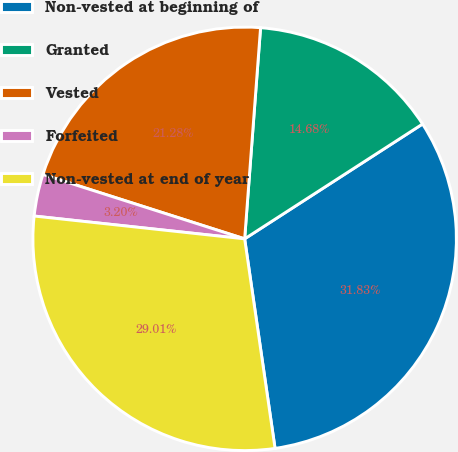Convert chart to OTSL. <chart><loc_0><loc_0><loc_500><loc_500><pie_chart><fcel>Non-vested at beginning of<fcel>Granted<fcel>Vested<fcel>Forfeited<fcel>Non-vested at end of year<nl><fcel>31.83%<fcel>14.68%<fcel>21.28%<fcel>3.2%<fcel>29.01%<nl></chart> 